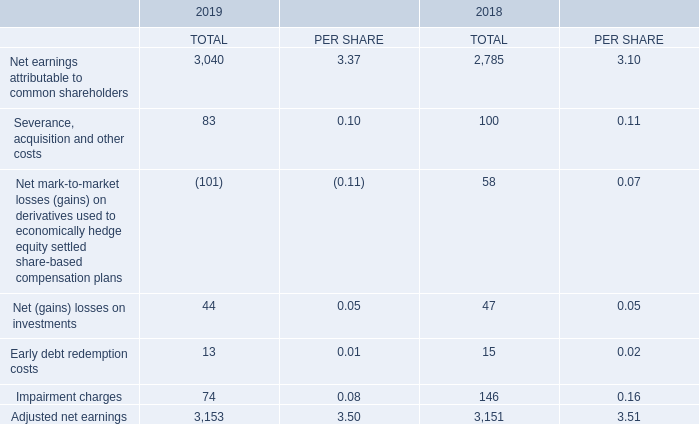ADJUSTED NET EARNINGS AND ADJUSTED EPS
The terms adjusted net earnings and adjusted EPS do not have any standardized meaning under IFRS. Therefore, they are unlikely to be comparable to similar measures presented by other issuers.
We define adjusted net earnings as net earnings attributable to common shareholders before severance, acquisition and other costs, net mark-to-market losses (gains) on derivatives used to economically hedge equity settled share-based compensation plans, net losses (gains) on investments, early debt redemption costs and impairment charges, net of tax and NCI. We define adjusted EPS as adjusted net earnings per BCE common share.
We use adjusted net earnings and adjusted EPS, and we believe that certain investors and analysts use these measures, among other ones, to assess the performance of our businesses without the effects of severance, acquisition and other costs, net mark-to-market losses (gains) on derivatives used to economically hedge equity settled share-based compensation plans, net losses (gains) on investments, early debt redemption costs and impairment charges, net of tax and NCI. We exclude these items because they affect the comparability of our financial results and could potentially distort the analysis of trends in business performance. Excluding these items does not imply they are non-recurring
The most comparable IFRS financial measures are net earnings attributable to common shareholders and EPS.
The following table is a reconciliation of net earnings attributable to common shareholders and EPS to adjusted net earnings on a consolidated basis and per BCE common share (adjusted EPS), respectively.
How is adjusted net earnings defined? Net earnings attributable to common shareholders before severance, acquisition and other costs, net mark-to-market losses (gains) on derivatives used to economically hedge equity settled share-based compensation plans, net losses (gains) on investments, early debt redemption costs and impairment charges, net of tax and nci. How is adjusted EPS defined? Adjusted net earnings per bce common share. What is the Net earnings attributable to common shareholders in total for 2019? 3,040. What is the change in net earnings attributable to common shareholders per share in 2019? 3.37-3.10
Answer: 0.27. What is net earnings attributable to common shareholders as a ratio of the adjusted net earnings in 2018?
Answer scale should be: percent. 2,785/3,151
Answer: 0.88. What is the total early debt redemption costs in 2018 and 2019? 13+15
Answer: 28. 